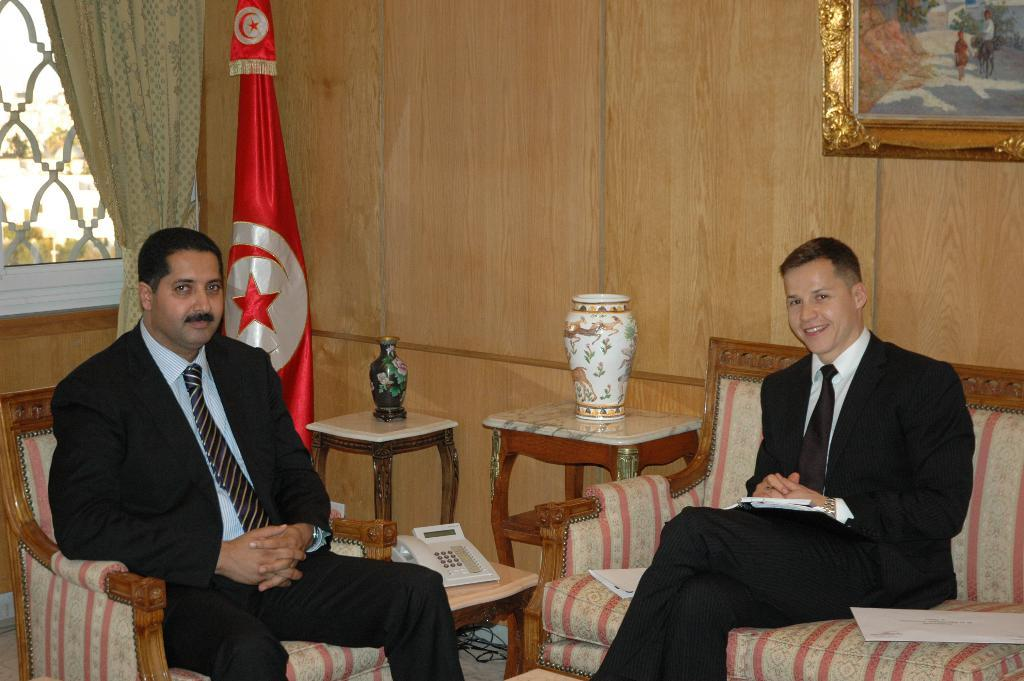How many people are in the image? There are two people in the image. What are the two people doing in the image? The two people are sitting on a couch. What is the facial expression of the people in the image? Both people are smiling. What type of poison is being used by the cook in the image? There is no cook or poison present in the image. What type of hook is visible on the wall in the image? There is no hook visible on the wall in the image. 